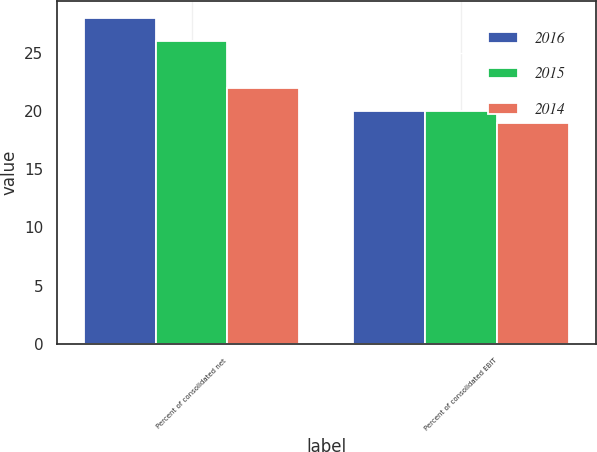<chart> <loc_0><loc_0><loc_500><loc_500><stacked_bar_chart><ecel><fcel>Percent of consolidated net<fcel>Percent of consolidated EBIT<nl><fcel>2016<fcel>28<fcel>20<nl><fcel>2015<fcel>26<fcel>20<nl><fcel>2014<fcel>22<fcel>19<nl></chart> 